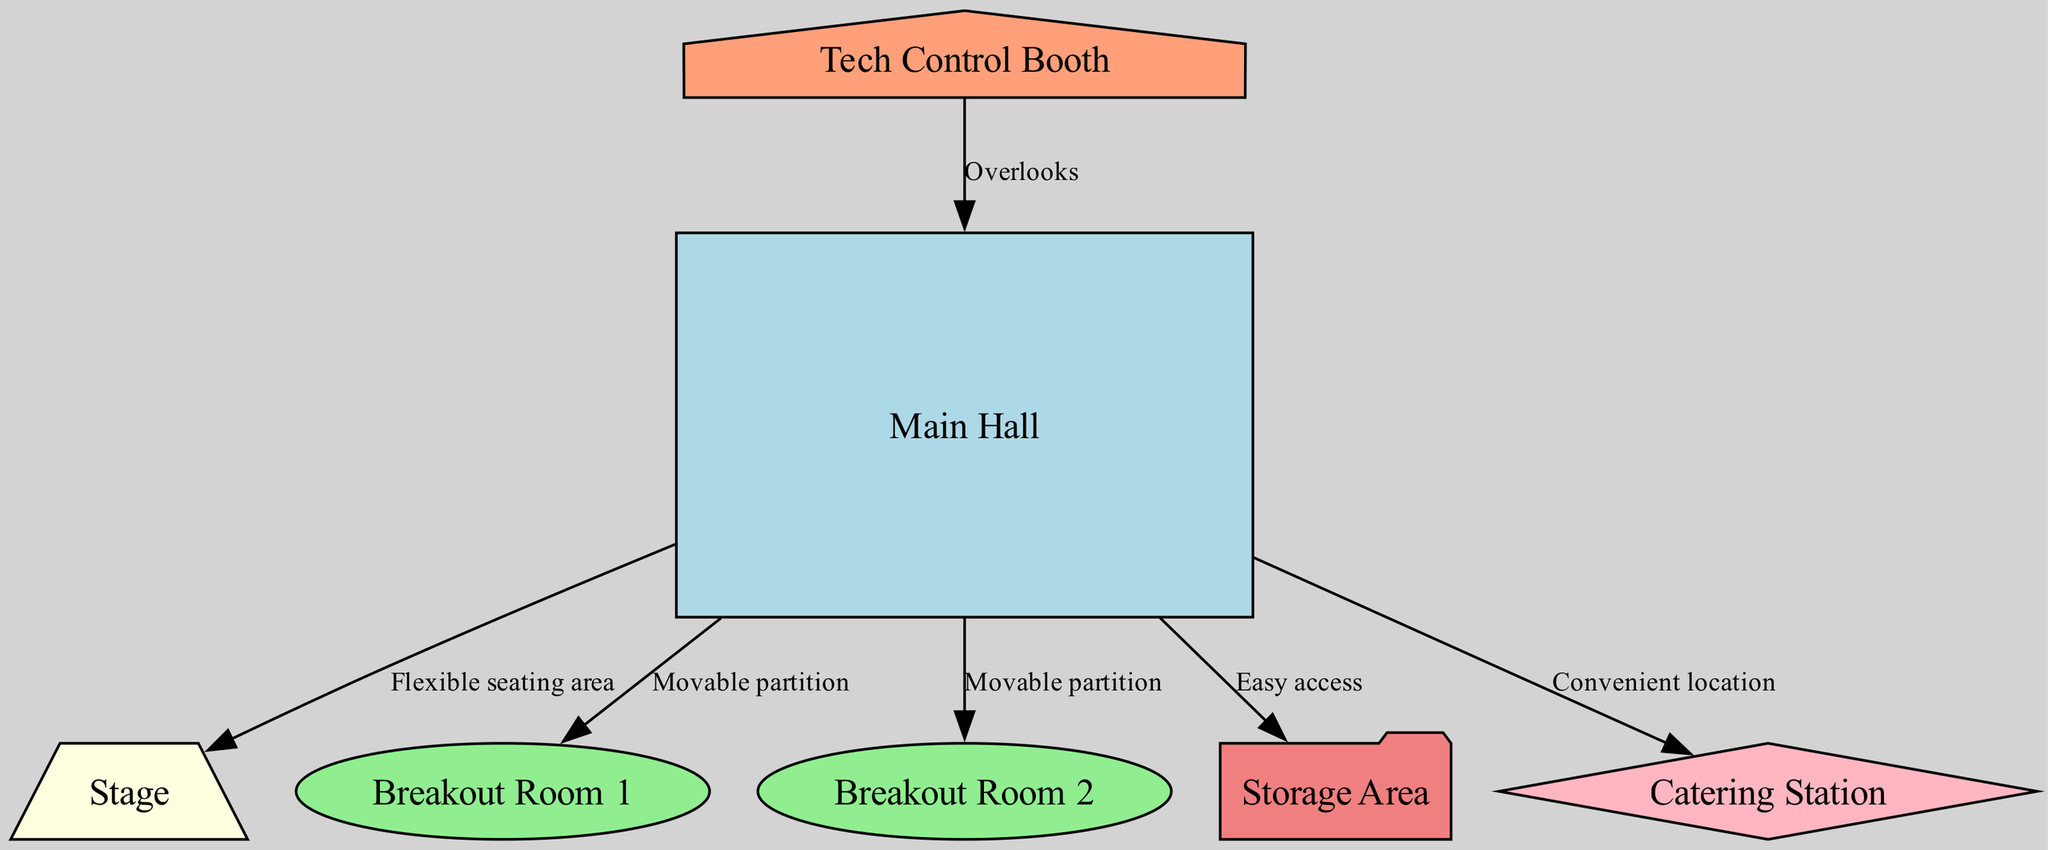What is the central area of the event space called? The diagram identifies the central area of the event space as "Main Hall."
Answer: Main Hall How many breakout rooms are included in the diagram? The diagram shows two breakout rooms labeled "Breakout Room 1" and "Breakout Room 2," indicating there are two breakout rooms.
Answer: 2 What is the shape of the stage in the diagram? The diagram depicts the stage as a trapezium, as indicated by its shape classification in the design.
Answer: Trapezium What does the tech control booth overlook? The edge from the tech booth to the main hall indicates that the tech control booth overlooks the main hall.
Answer: Main Hall Which area provides easy access from the main hall? According to the diagram, the storage area is directly connected to the main hall with the label "Easy access."
Answer: Storage Area What color represents the catering station in the diagram? The catering station is filled with a light pink color as shown in the diagram's node attributes.
Answer: Light Pink How is the seating area described in relation to the stage? The edge connecting the main hall to the stage is labeled "Flexible seating area," indicating its adaptability.
Answer: Flexible seating area Which two rooms are separated by a movable partition? The diagram illustrates that both breakout room 1 and breakout room 2 are linked to the main hall by edges labeled "Movable partition."
Answer: Breakout Room 1 and Breakout Room 2 What type of structure is the storage area represented as? In the diagram, the storage area is depicted in the shape of a folder, highlighting its function and design in the layout.
Answer: Folder 